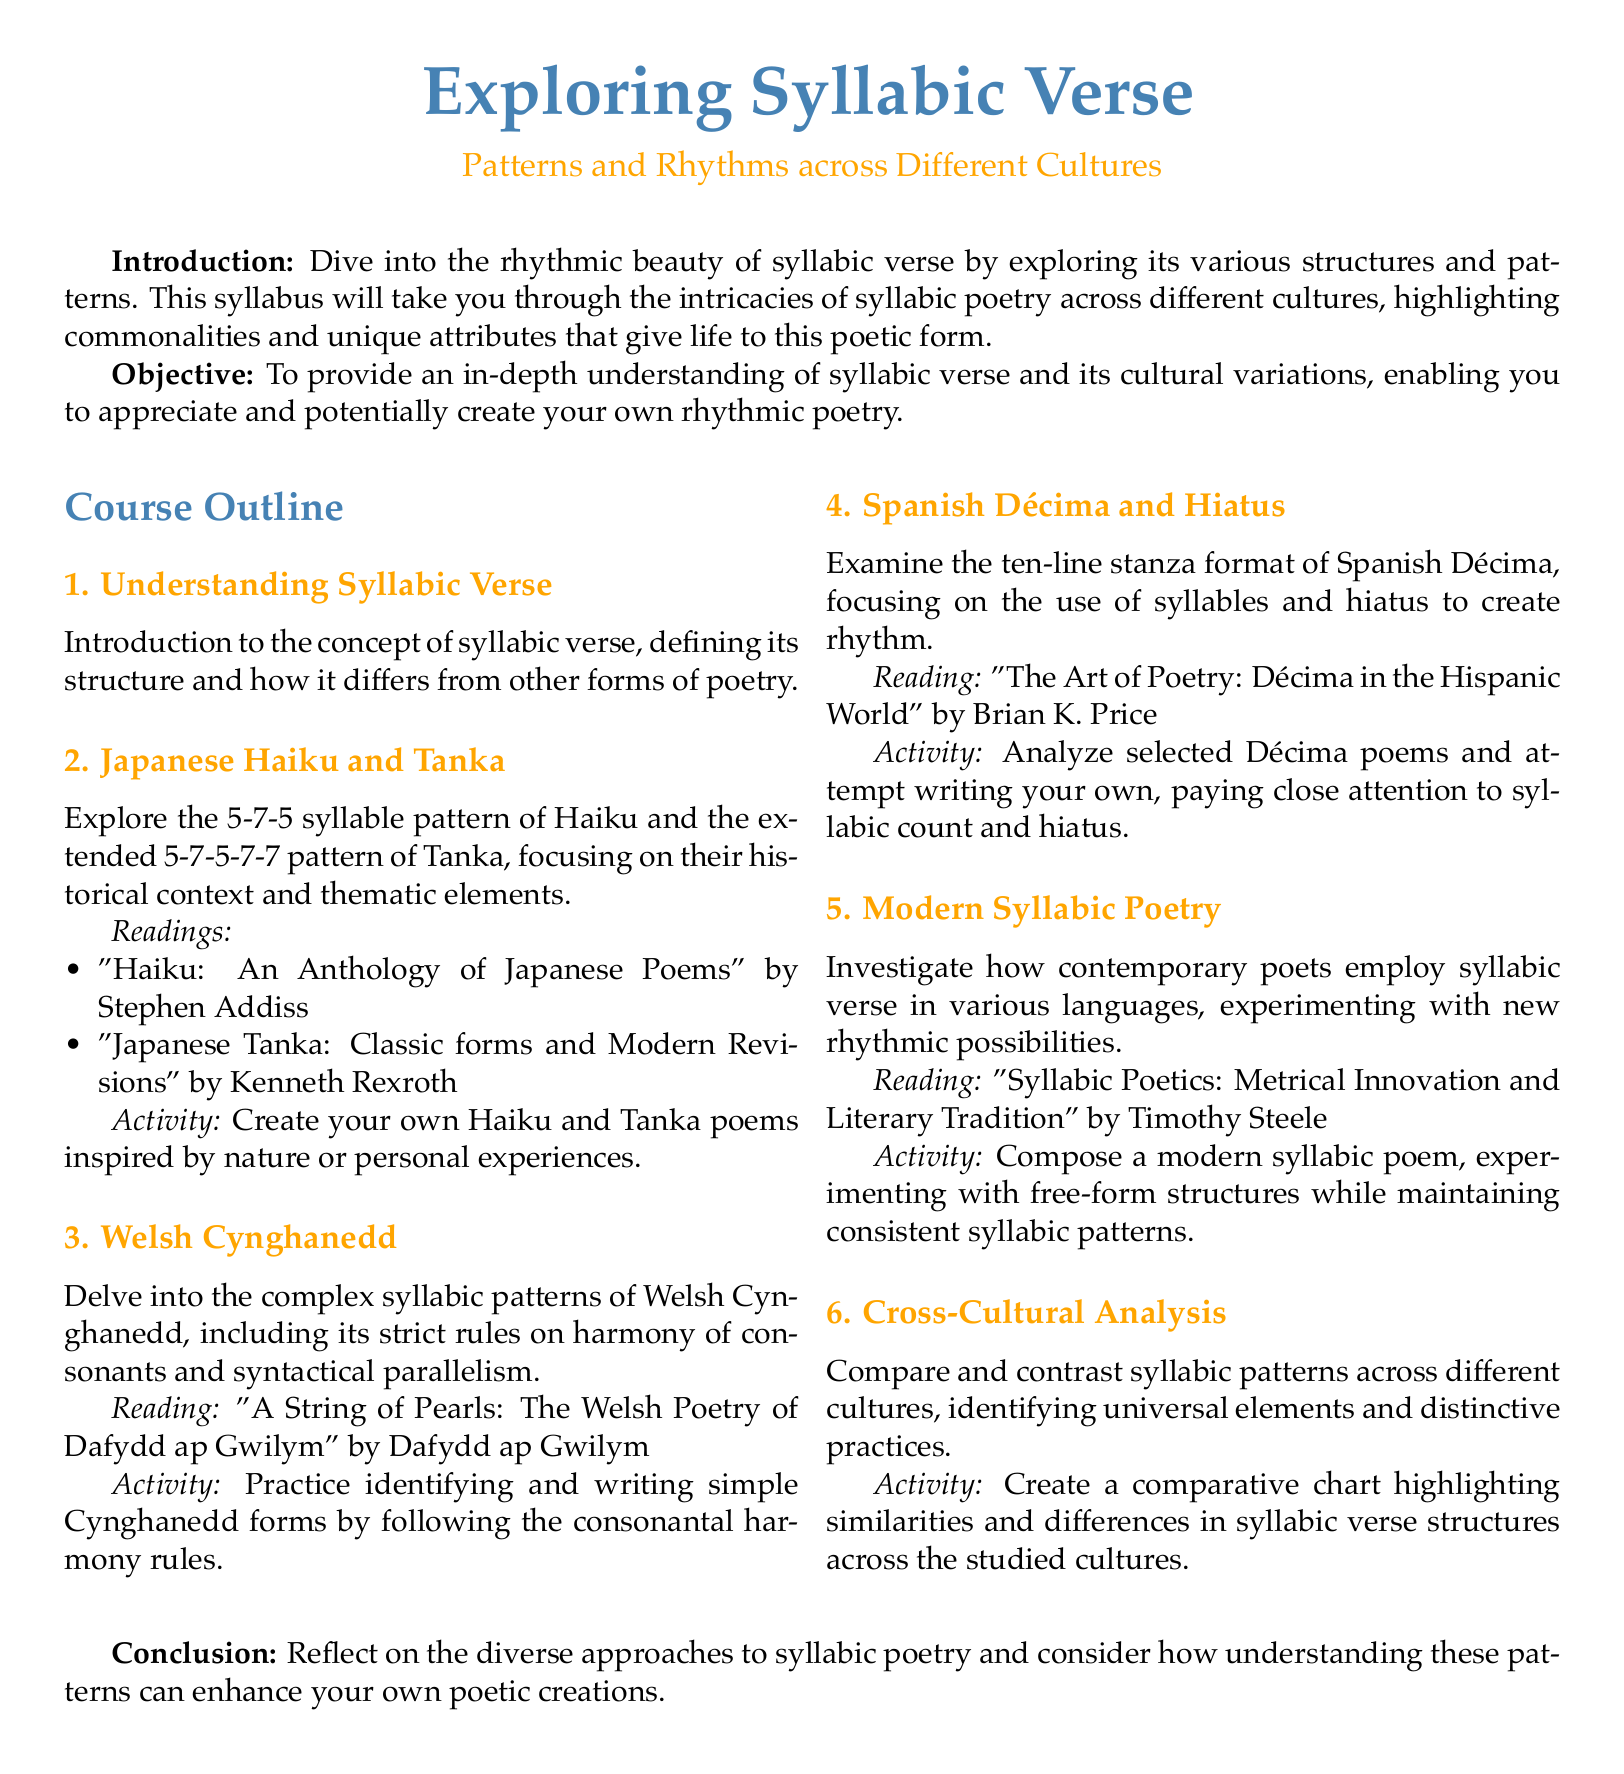What is the title of the syllabus? The title appears at the top of the document, indicating the focus of the course.
Answer: Exploring Syllabic Verse What type of poetry is primarily explored in this syllabus? This is the main subject matter detailed throughout the document.
Answer: Syllabic verse How many syllables are in a Haiku? The syllabus specifies the syllable structure of a Haiku in the course outline.
Answer: 5-7-5 What activity is suggested for creating a Haiku? This refers to the specific activity outlined for students to engage with the form.
Answer: Inspired by nature or personal experiences Who is the author of "A String of Pearls"? The author of the significant reading material for understanding Welsh Cynghanedd is mentioned.
Answer: Dafydd ap Gwilym What is the focus of the fourth section in the syllabus? This question pertains to the main content of the section regarding a specific poetic form.
Answer: Spanish Décima and Hiatus What type of analysis is applied in the sixth section? This describes the comparative approach taken in the final section of the syllabus.
Answer: Cross-Cultural Analysis What is the aim of the course? This outlines the primary goal which is presented in the objective section.
Answer: In-depth understanding of syllabic verse What is a key reading for understanding Modern Syllabic Poetry? This refers to an important source for the study of contemporary syllabic verse.
Answer: Syllabic Poetics: Metrical Innovation and Literary Tradition 